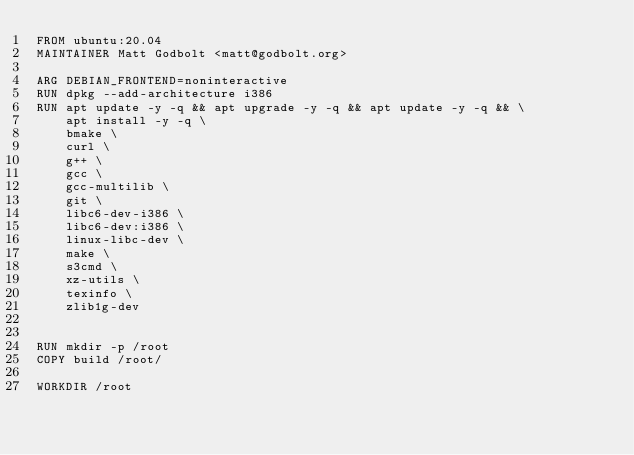Convert code to text. <code><loc_0><loc_0><loc_500><loc_500><_Dockerfile_>FROM ubuntu:20.04
MAINTAINER Matt Godbolt <matt@godbolt.org>

ARG DEBIAN_FRONTEND=noninteractive
RUN dpkg --add-architecture i386
RUN apt update -y -q && apt upgrade -y -q && apt update -y -q && \
    apt install -y -q \
    bmake \
    curl \
    g++ \
    gcc \
    gcc-multilib \
    git \
    libc6-dev-i386 \
    libc6-dev:i386 \
    linux-libc-dev \
    make \
    s3cmd \
    xz-utils \
    texinfo \
    zlib1g-dev


RUN mkdir -p /root
COPY build /root/

WORKDIR /root
</code> 